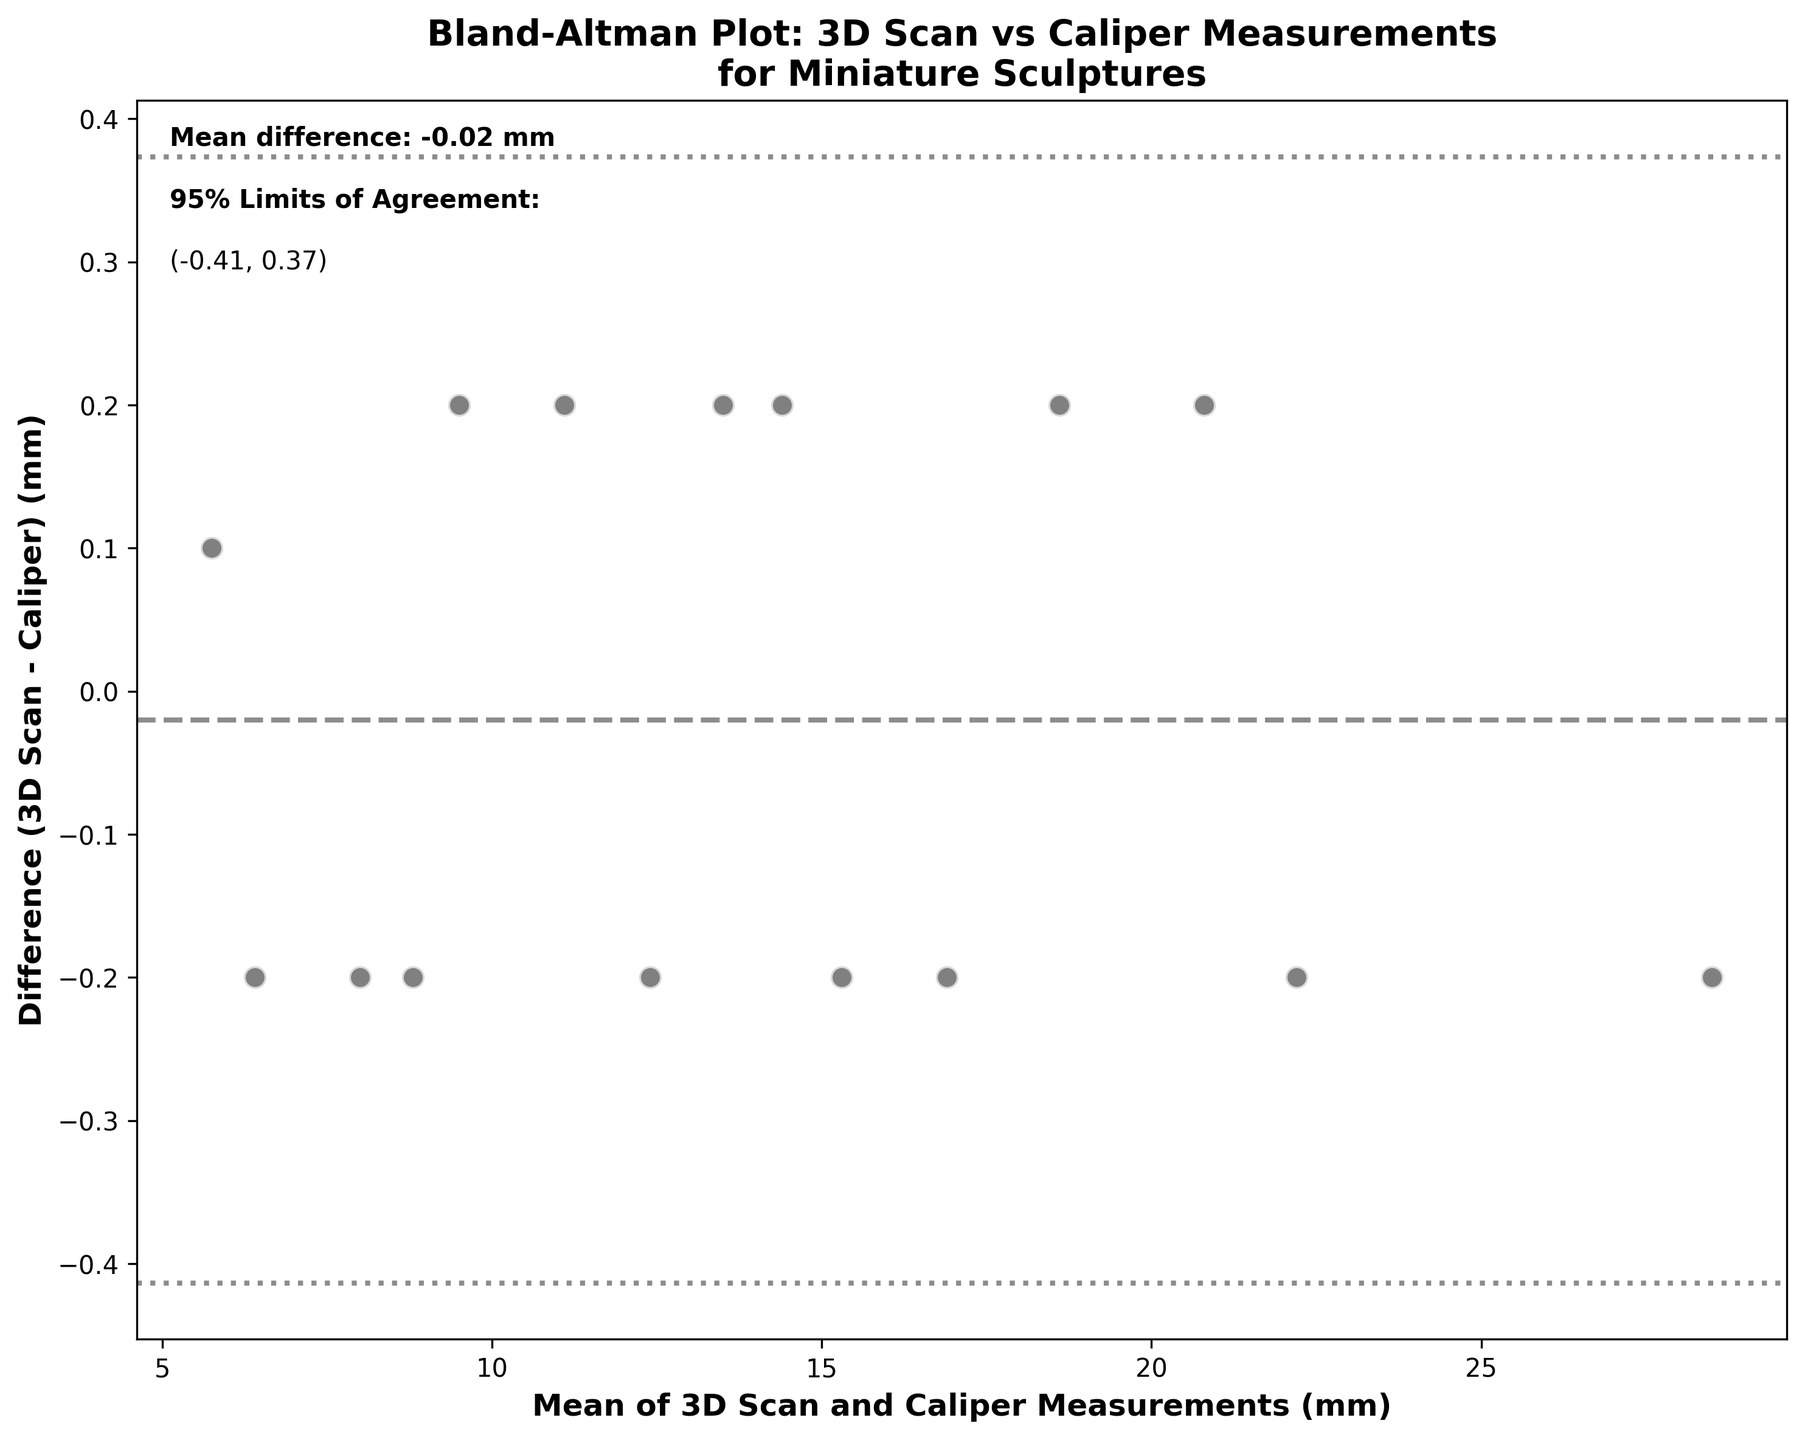What is the mean difference between 3D Scan and Caliper measurements? The mean difference is shown as a horizontal dashed line on the plot, labeled "Mean difference: 0.00 mm".
Answer: 0.00 mm What are the 95% limits of agreement? The 95% limits of agreement are indicated by horizontal dotted lines on the plot. They are labeled as "95% Limits of Agreement: (-0.25, 0.25)".
Answer: (-0.25, 0.25) mm How many data points are shown in the plot? By counting the individual scatter points on the plot representing the sculptures, we find there are 15 data points.
Answer: 15 Which sculpture has the largest difference between 3D Scan and Caliper measurements, and what is that difference? The sculpture with the largest difference is indicated by the farthest point from the x-axis. For the "Snuff_Bottle_Stopper," the difference is 3D_Scan_mm minus Caliper_mm, which is 6.3 - 6.5 = -0.2 mm.
Answer: Snuff_Bottle_Stopper, -0.2 mm Where does the "Ojime_Bead" point lie with respect to the mean difference and the limits of agreement? The "Ojime_Bead" point's average is around 5.75 mm. The difference is small and near the mean difference line at 0.00 mm. It lies well within the 95% limits of agreement.
Answer: Near mean, within limits Which sculpture has the smallest average dimension, and what is that dimension? By examining the x-axis (Mean of 3D Scan and Caliper Measurements), the "Ojime_Bead" has the smallest average dimension of 5.75 mm.
Answer: Ojime_Bead, 5.75 mm Are all data points within the 95% limits of agreement? Yes, all data points fall between the horizontal dotted lines representing the 95% limits of agreement, from -0.25 mm to 0.25 mm.
Answer: Yes Is there a trend in the differences as the mean value increases? By observing the scatter points, there doesn't appear to be a systematic trend where the differences increase or decrease with higher mean values. They are fairly evenly distributed around the mean difference line.
Answer: No systematic trend What is the average dimension of the "Kagamibuta_Disc" according to the plot? The "Kagamibuta_Disc" point is located at an average value around 9.5 mm on the x-axis.
Answer: 9.5 mm Is the calibration of the 3D scanner accurate according to this plot? Since the mean difference is near zero (0.00 mm), and all points fall within the 95% limits of agreement, it suggests that the 3D scanner measurements agree closely with the caliper measurements.
Answer: Yes 